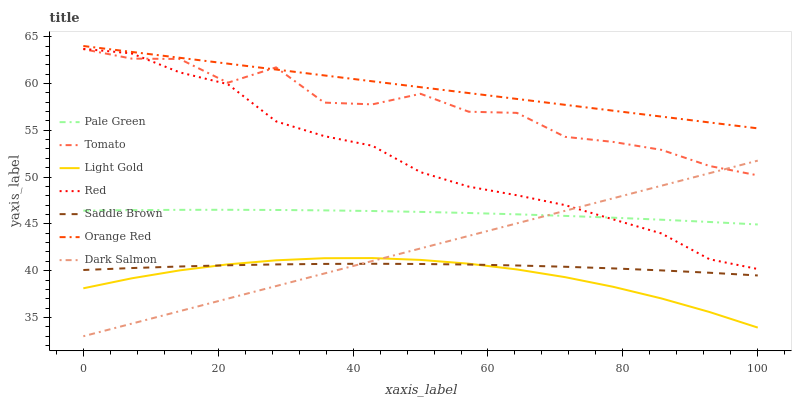Does Light Gold have the minimum area under the curve?
Answer yes or no. Yes. Does Orange Red have the maximum area under the curve?
Answer yes or no. Yes. Does Dark Salmon have the minimum area under the curve?
Answer yes or no. No. Does Dark Salmon have the maximum area under the curve?
Answer yes or no. No. Is Orange Red the smoothest?
Answer yes or no. Yes. Is Tomato the roughest?
Answer yes or no. Yes. Is Dark Salmon the smoothest?
Answer yes or no. No. Is Dark Salmon the roughest?
Answer yes or no. No. Does Dark Salmon have the lowest value?
Answer yes or no. Yes. Does Orange Red have the lowest value?
Answer yes or no. No. Does Orange Red have the highest value?
Answer yes or no. Yes. Does Dark Salmon have the highest value?
Answer yes or no. No. Is Saddle Brown less than Red?
Answer yes or no. Yes. Is Pale Green greater than Saddle Brown?
Answer yes or no. Yes. Does Light Gold intersect Saddle Brown?
Answer yes or no. Yes. Is Light Gold less than Saddle Brown?
Answer yes or no. No. Is Light Gold greater than Saddle Brown?
Answer yes or no. No. Does Saddle Brown intersect Red?
Answer yes or no. No. 